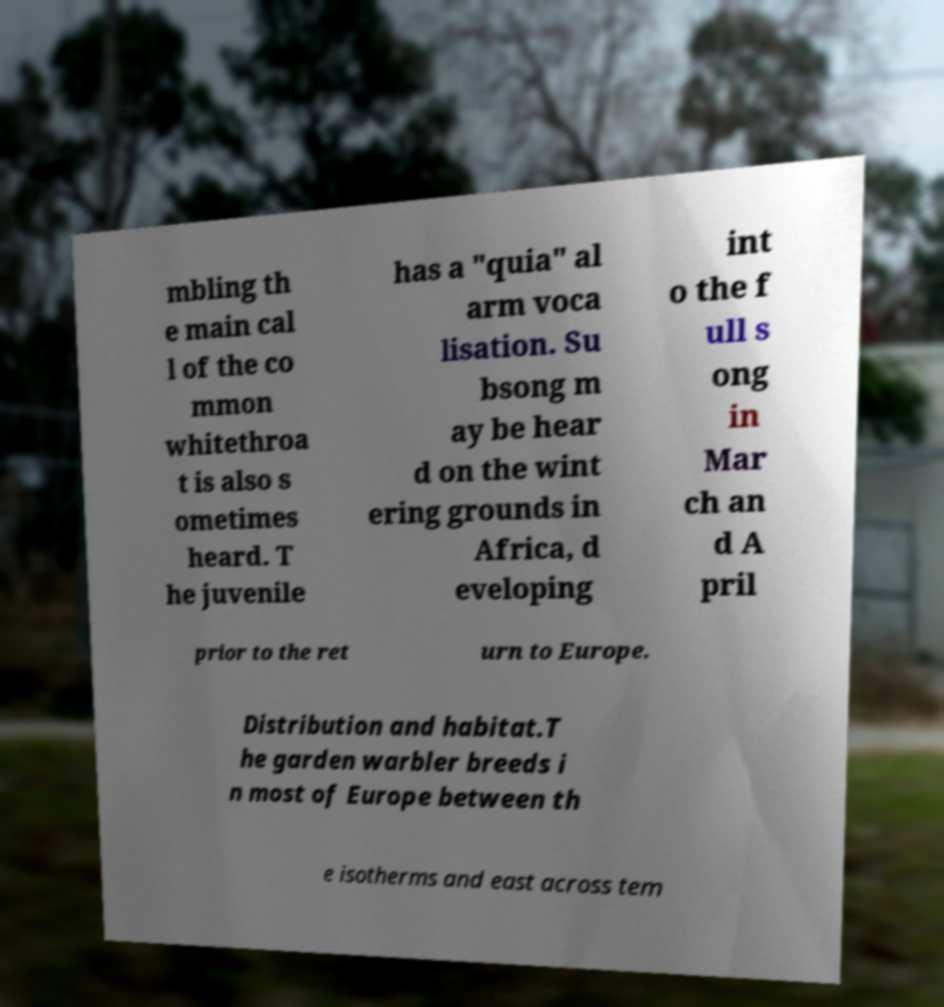For documentation purposes, I need the text within this image transcribed. Could you provide that? mbling th e main cal l of the co mmon whitethroa t is also s ometimes heard. T he juvenile has a "quia" al arm voca lisation. Su bsong m ay be hear d on the wint ering grounds in Africa, d eveloping int o the f ull s ong in Mar ch an d A pril prior to the ret urn to Europe. Distribution and habitat.T he garden warbler breeds i n most of Europe between th e isotherms and east across tem 